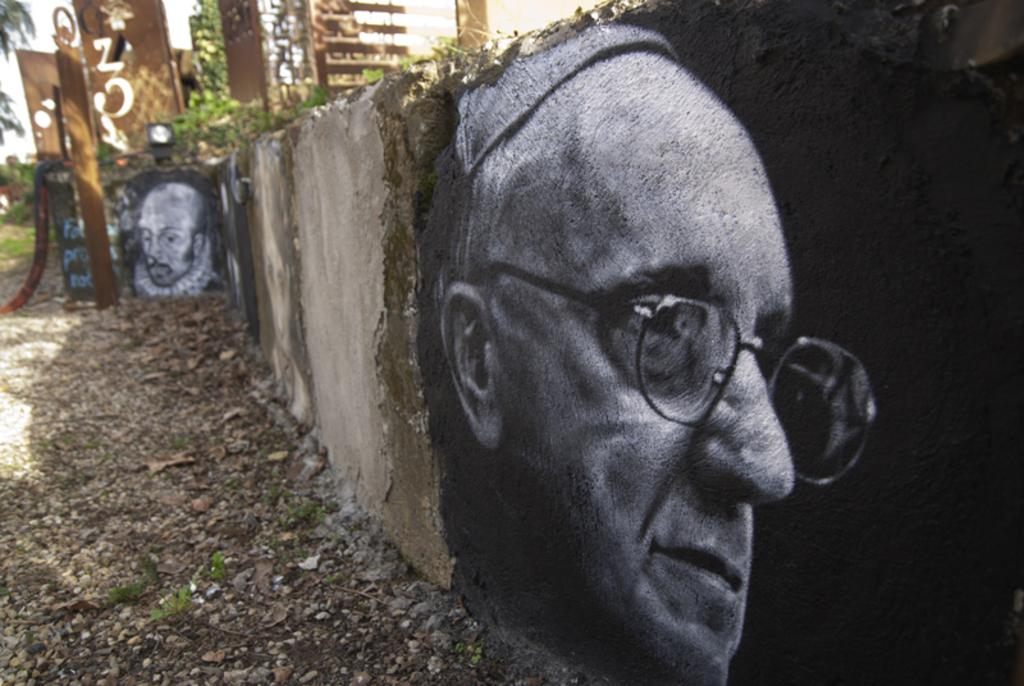What is on the wall in the image? There is a painting on the wall in the image. What is the subject matter of the painting? The painting depicts two faces of a person. Can you see a lake in the background of the painting? There is no lake visible in the painting; it only depicts two faces of a person. Is there a watch present in the painting? There is no watch present in the painting; it only depicts two faces of a person. 